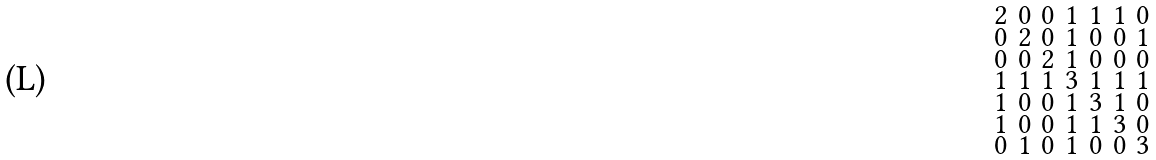<formula> <loc_0><loc_0><loc_500><loc_500>\begin{smallmatrix} 2 & 0 & 0 & 1 & 1 & 1 & 0 \\ 0 & 2 & 0 & 1 & 0 & 0 & 1 \\ 0 & 0 & 2 & 1 & 0 & 0 & 0 \\ 1 & 1 & 1 & 3 & 1 & 1 & 1 \\ 1 & 0 & 0 & 1 & 3 & 1 & 0 \\ 1 & 0 & 0 & 1 & 1 & 3 & 0 \\ 0 & 1 & 0 & 1 & 0 & 0 & 3 \end{smallmatrix}</formula> 